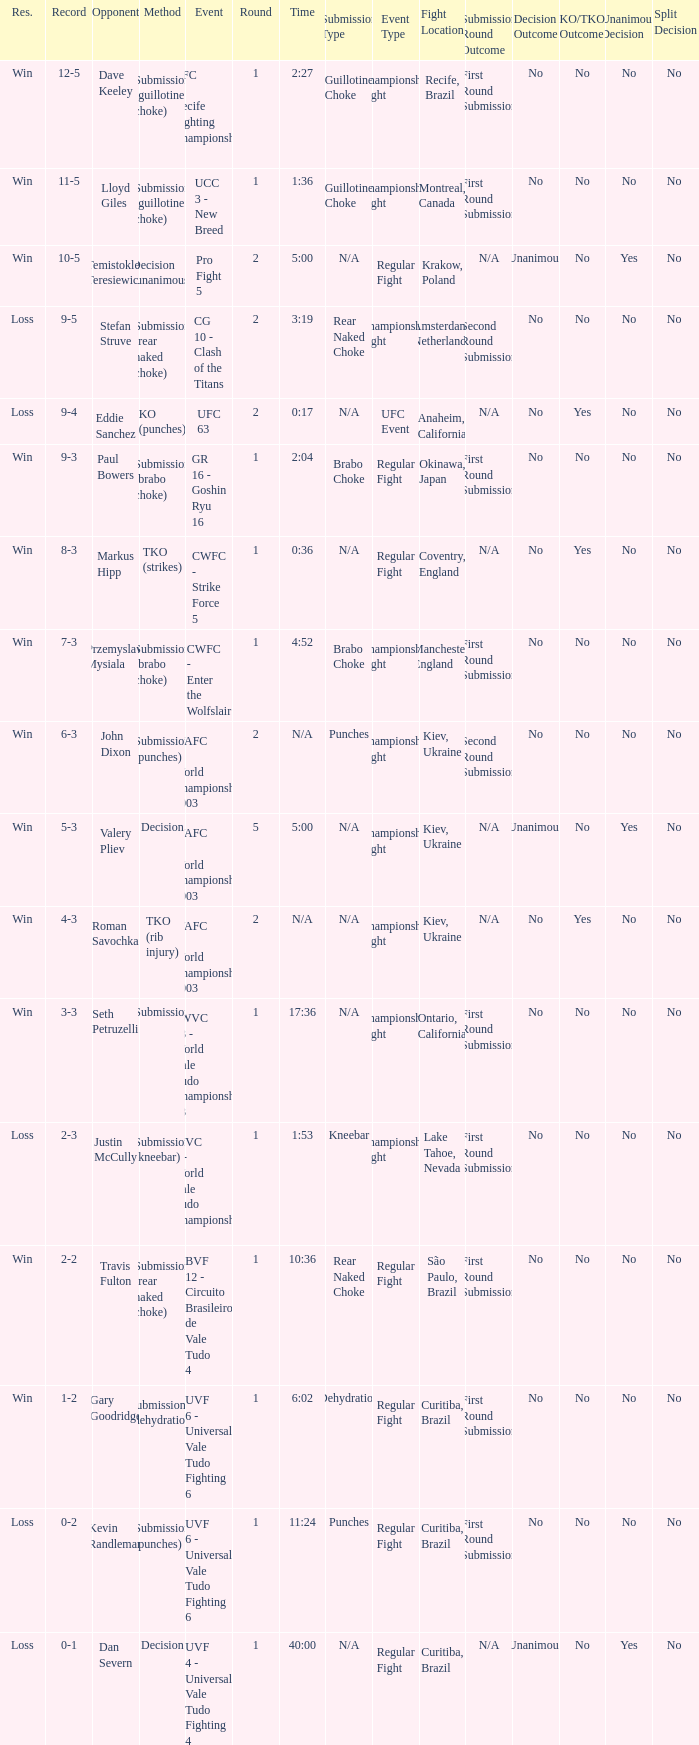What round has the highest Res loss, and a time of 40:00? 1.0. 